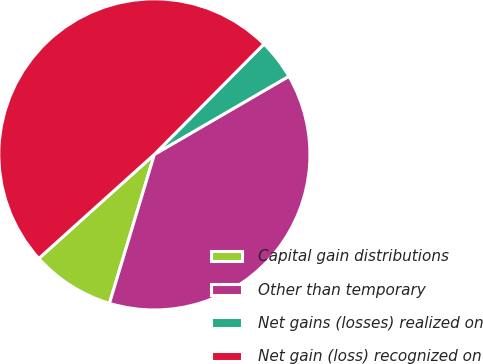Convert chart. <chart><loc_0><loc_0><loc_500><loc_500><pie_chart><fcel>Capital gain distributions<fcel>Other than temporary<fcel>Net gains (losses) realized on<fcel>Net gain (loss) recognized on<nl><fcel>8.67%<fcel>38.04%<fcel>4.18%<fcel>49.11%<nl></chart> 